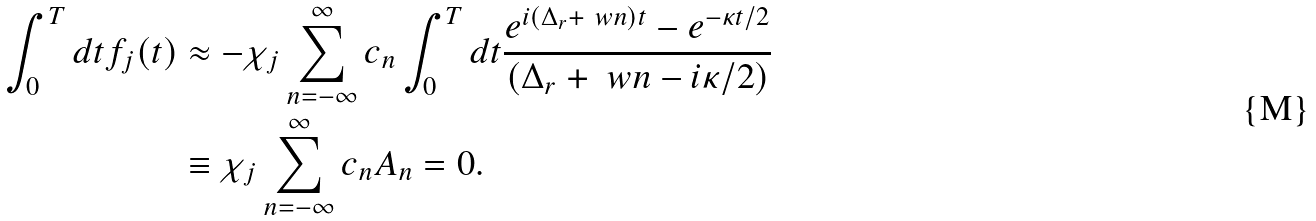<formula> <loc_0><loc_0><loc_500><loc_500>\int _ { 0 } ^ { T } d t f _ { j } ( t ) & \approx - \chi _ { j } \sum _ { n = - \infty } ^ { \infty } c _ { n } \int _ { 0 } ^ { T } d t \frac { e ^ { i ( \Delta _ { r } + \ w { n } ) t } - e ^ { - \kappa t / 2 } } { ( \Delta _ { r } + \ w { n } - i \kappa / 2 ) } \\ & \equiv \chi _ { j } \sum _ { n = - \infty } ^ { \infty } c _ { n } A _ { n } = 0 .</formula> 